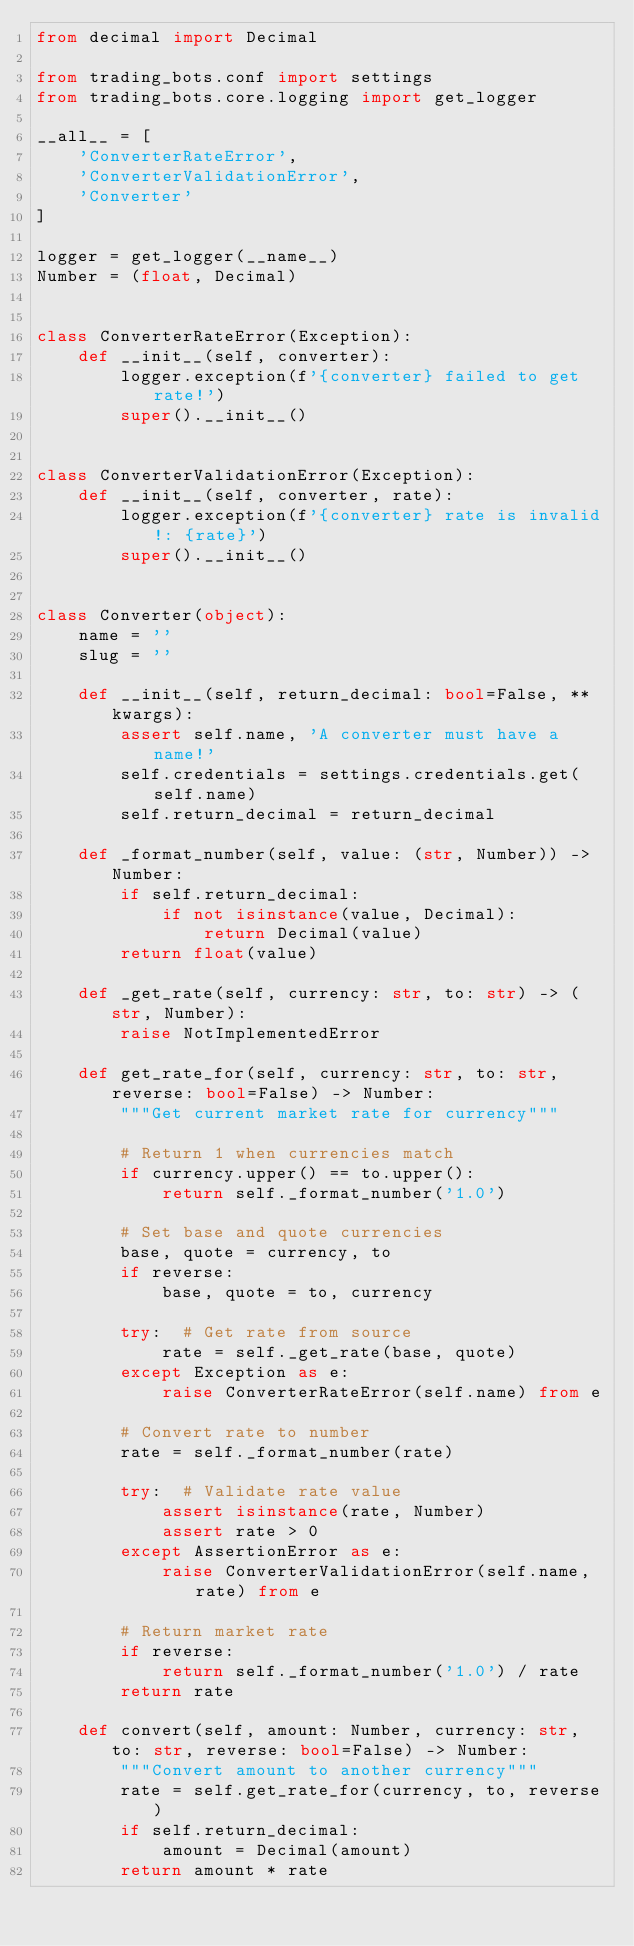Convert code to text. <code><loc_0><loc_0><loc_500><loc_500><_Python_>from decimal import Decimal

from trading_bots.conf import settings
from trading_bots.core.logging import get_logger

__all__ = [
    'ConverterRateError',
    'ConverterValidationError',
    'Converter'
]

logger = get_logger(__name__)
Number = (float, Decimal)


class ConverterRateError(Exception):
    def __init__(self, converter):
        logger.exception(f'{converter} failed to get rate!')
        super().__init__()


class ConverterValidationError(Exception):
    def __init__(self, converter, rate):
        logger.exception(f'{converter} rate is invalid!: {rate}')
        super().__init__()


class Converter(object):
    name = ''
    slug = ''

    def __init__(self, return_decimal: bool=False, **kwargs):
        assert self.name, 'A converter must have a name!'
        self.credentials = settings.credentials.get(self.name)
        self.return_decimal = return_decimal

    def _format_number(self, value: (str, Number)) -> Number:
        if self.return_decimal:
            if not isinstance(value, Decimal):
                return Decimal(value)
        return float(value)

    def _get_rate(self, currency: str, to: str) -> (str, Number):
        raise NotImplementedError

    def get_rate_for(self, currency: str, to: str, reverse: bool=False) -> Number:
        """Get current market rate for currency"""

        # Return 1 when currencies match
        if currency.upper() == to.upper():
            return self._format_number('1.0')

        # Set base and quote currencies
        base, quote = currency, to
        if reverse:
            base, quote = to, currency

        try:  # Get rate from source
            rate = self._get_rate(base, quote)
        except Exception as e:
            raise ConverterRateError(self.name) from e

        # Convert rate to number
        rate = self._format_number(rate)

        try:  # Validate rate value
            assert isinstance(rate, Number)
            assert rate > 0
        except AssertionError as e:
            raise ConverterValidationError(self.name, rate) from e

        # Return market rate
        if reverse:
            return self._format_number('1.0') / rate
        return rate

    def convert(self, amount: Number, currency: str, to: str, reverse: bool=False) -> Number:
        """Convert amount to another currency"""
        rate = self.get_rate_for(currency, to, reverse)
        if self.return_decimal:
            amount = Decimal(amount)
        return amount * rate
</code> 